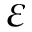Convert formula to latex. <formula><loc_0><loc_0><loc_500><loc_500>\varepsilon</formula> 